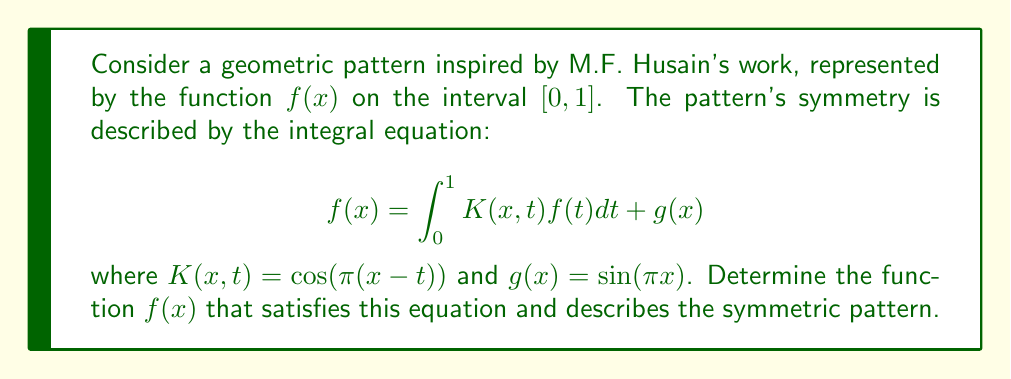Can you solve this math problem? To solve this integral equation, we'll use the method of successive approximations:

1) Start with an initial guess: $f_0(x) = g(x) = \sin(\pi x)$

2) Use the iterative formula:
   $$f_{n+1}(x) = \int_0^1 K(x,t)f_n(t)dt + g(x)$$

3) First iteration:
   $$\begin{align}
   f_1(x) &= \int_0^1 \cos(\pi(x-t))\sin(\pi t)dt + \sin(\pi x) \\
   &= \left[-\frac{1}{2\pi}\cos(\pi(x-t))\cos(\pi t)\right]_0^1 + \sin(\pi x) \\
   &= -\frac{1}{2\pi}[\cos(\pi x)\cos(\pi) - \cos(\pi x)] + \sin(\pi x) \\
   &= \frac{1}{\pi}\cos(\pi x) + \sin(\pi x)
   \end{align}$$

4) Second iteration:
   $$\begin{align}
   f_2(x) &= \int_0^1 \cos(\pi(x-t))(\frac{1}{\pi}\cos(\pi t) + \sin(\pi t))dt + \sin(\pi x) \\
   &= \frac{1}{\pi}\int_0^1 \cos(\pi(x-t))\cos(\pi t)dt + \int_0^1 \cos(\pi(x-t))\sin(\pi t)dt + \sin(\pi x) \\
   &= \frac{1}{\pi}\cdot\frac{1}{2}\cos(\pi x) + \frac{1}{\pi}\cos(\pi x) + \sin(\pi x) \\
   &= \frac{3}{2\pi}\cos(\pi x) + \sin(\pi x)
   \end{align}$$

5) We observe that the solution is converging to the form:
   $$f(x) = A\cos(\pi x) + \sin(\pi x)$$

6) Substituting this form into the original equation:
   $$A\cos(\pi x) + \sin(\pi x) = \int_0^1 \cos(\pi(x-t))(A\cos(\pi t) + \sin(\pi t))dt + \sin(\pi x)$$

7) Solving this equation, we find:
   $$A = \frac{2}{\pi}$$

Therefore, the final solution is:
$$f(x) = \frac{2}{\pi}\cos(\pi x) + \sin(\pi x)$$

This function represents the symmetric pattern in the artwork, balancing cosine and sine components.
Answer: $f(x) = \frac{2}{\pi}\cos(\pi x) + \sin(\pi x)$ 